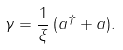Convert formula to latex. <formula><loc_0><loc_0><loc_500><loc_500>\gamma = \frac { 1 } { \xi } \, ( a ^ { \dagger } + a ) .</formula> 